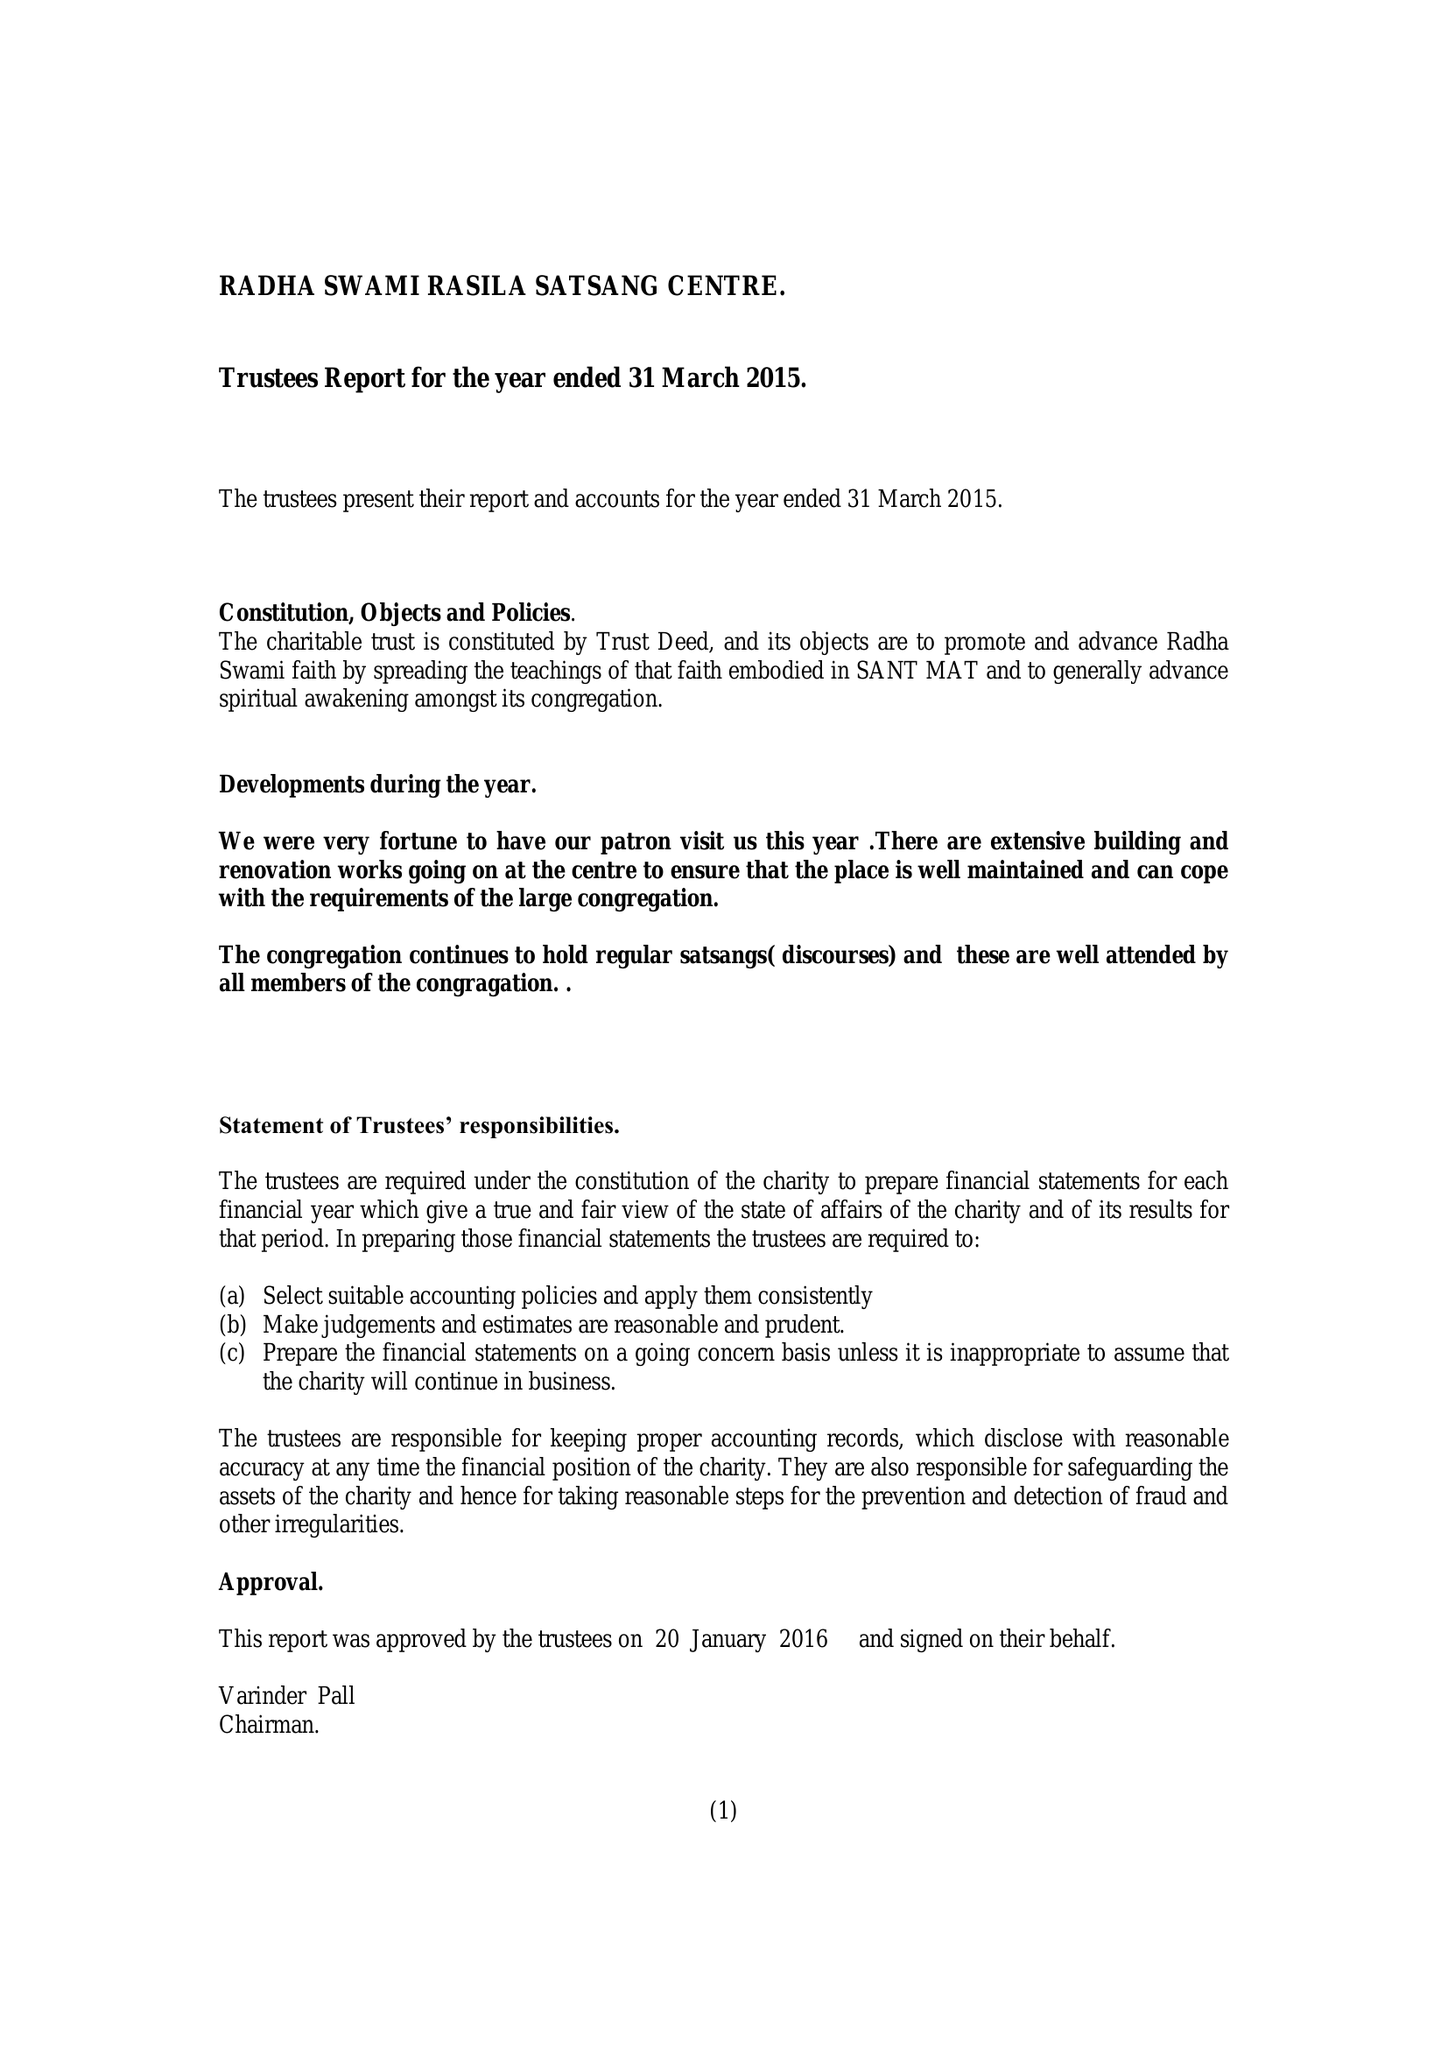What is the value for the report_date?
Answer the question using a single word or phrase. 2015-03-31 